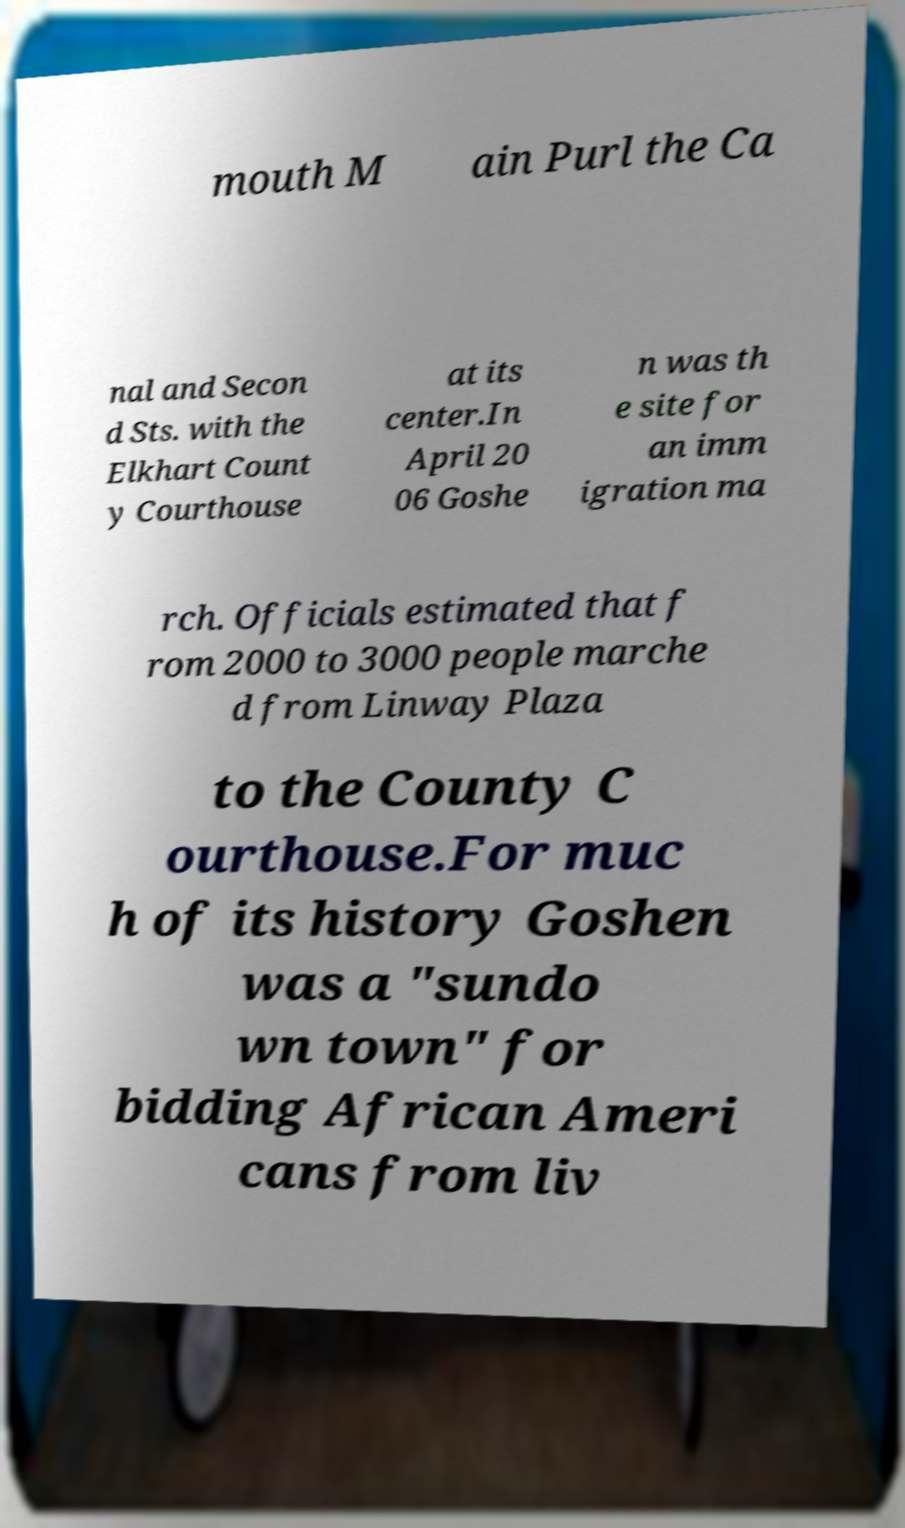For documentation purposes, I need the text within this image transcribed. Could you provide that? mouth M ain Purl the Ca nal and Secon d Sts. with the Elkhart Count y Courthouse at its center.In April 20 06 Goshe n was th e site for an imm igration ma rch. Officials estimated that f rom 2000 to 3000 people marche d from Linway Plaza to the County C ourthouse.For muc h of its history Goshen was a "sundo wn town" for bidding African Ameri cans from liv 